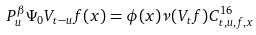<formula> <loc_0><loc_0><loc_500><loc_500>P _ { u } ^ { \beta } \Psi _ { 0 } V _ { t - u } f ( x ) = \phi ( x ) \nu ( V _ { t } f ) C ^ { 1 6 } _ { t , u , f , x }</formula> 